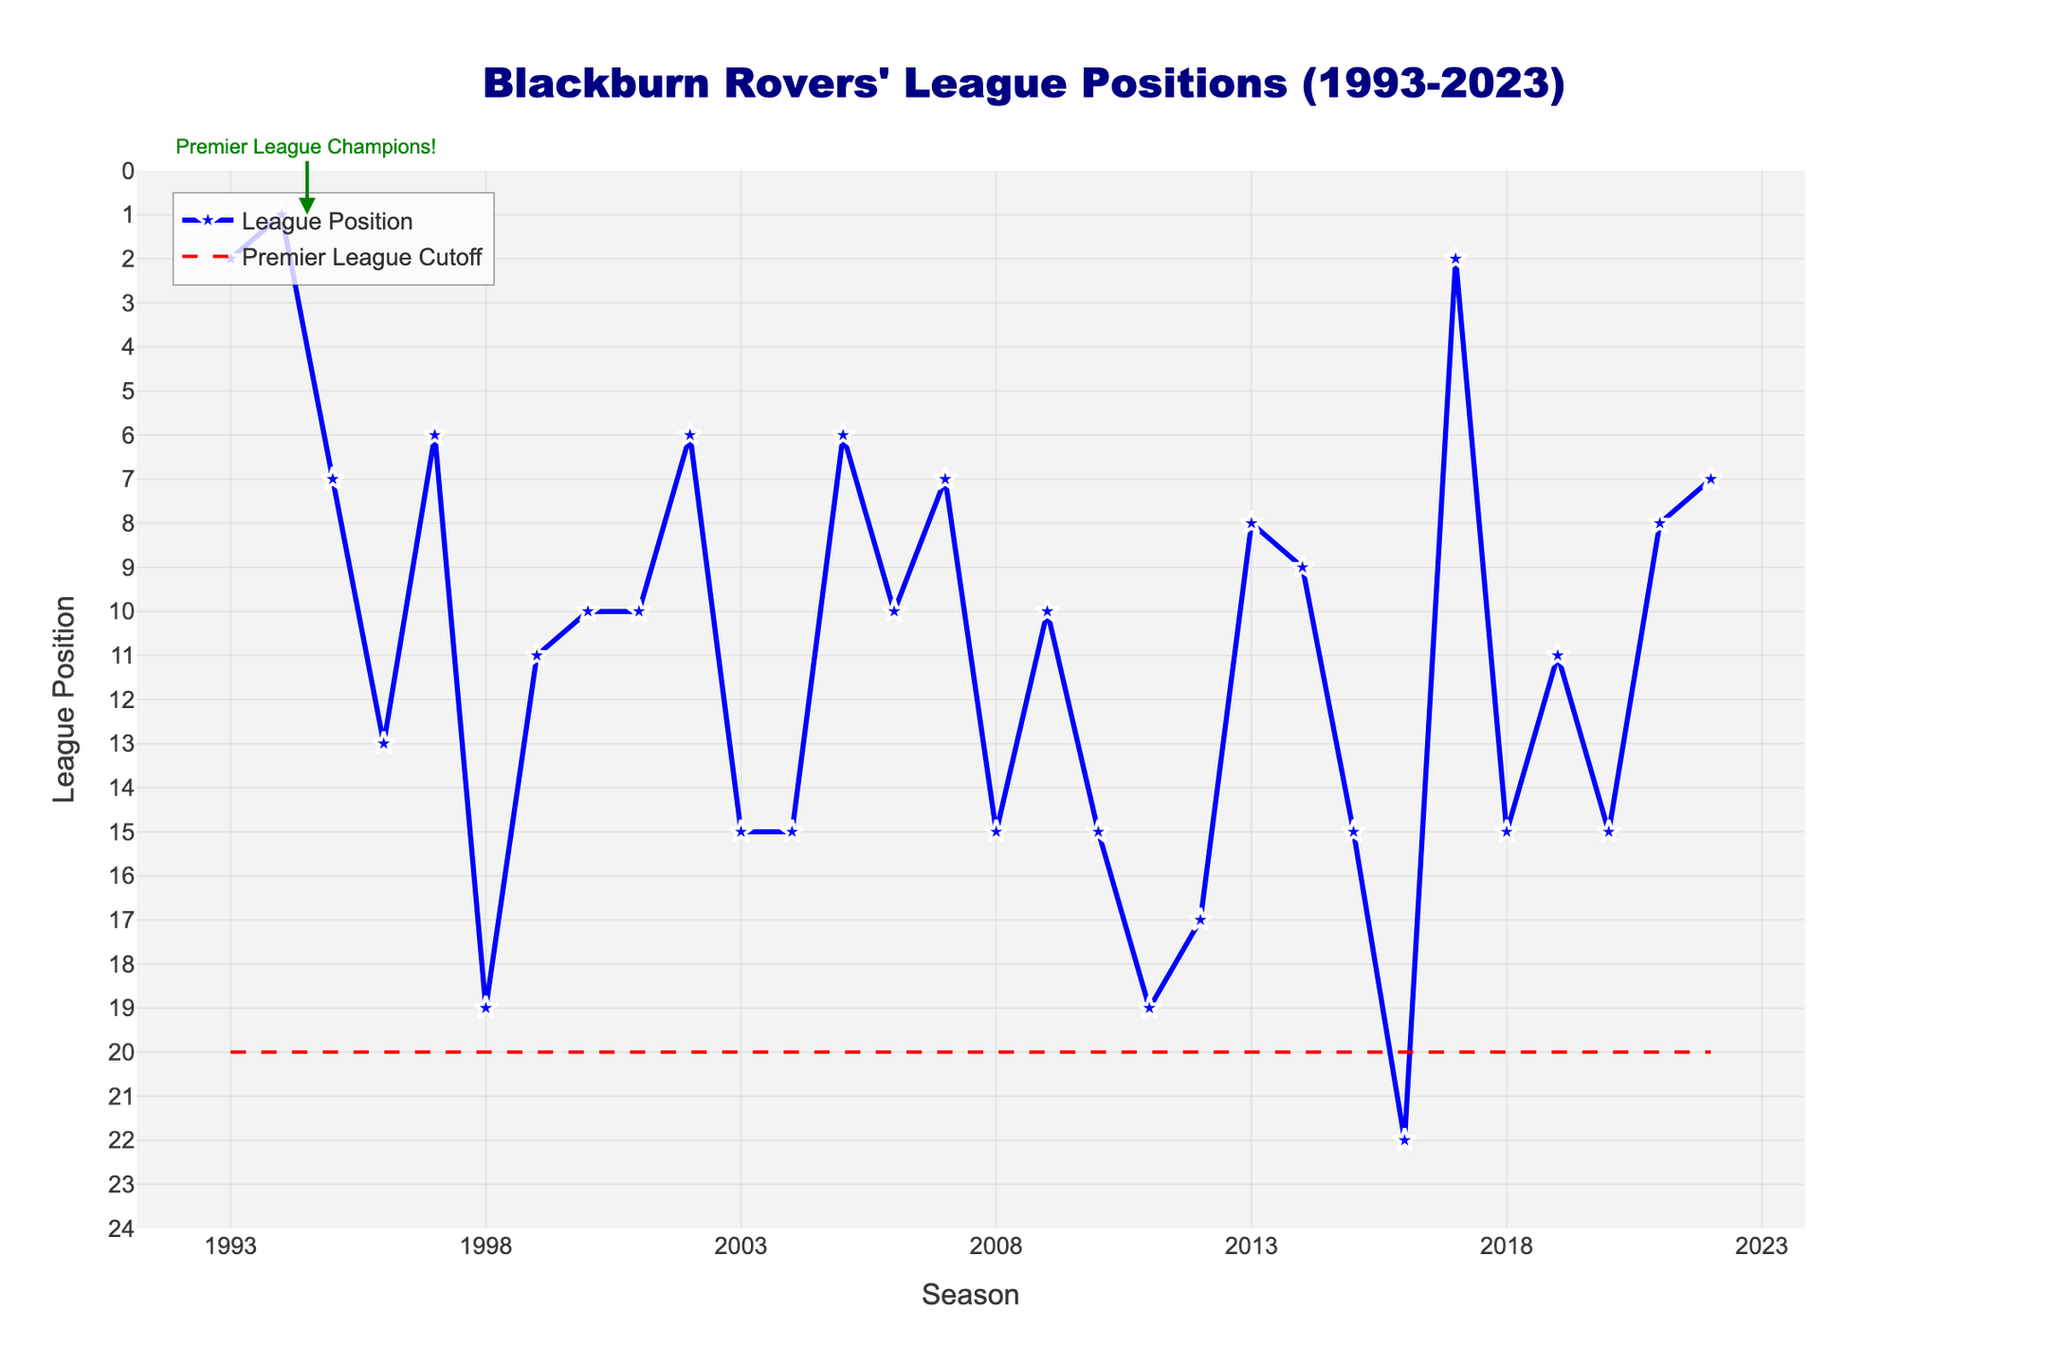What's the best league position Blackburn Rovers achieved in the past 30 seasons? The highest position Blackburn Rovers achieved is marked as 1 in the 1994-95 season. This is the lowest point on the y-axis.
Answer: 1 How many seasons did Blackburn Rovers finish in a position below the Premier League cutoff (above 20th position)? The figure shows 3 seasons where Blackburn Rovers finished above the 20th position line: 1998-99, 2011-12, and 2016-17.
Answer: 3 What is the range of league positions Blackburn Rovers occupied between the 2000-01 season and the 2004-05 season, inclusive? From the plot, the positions are:
2000-01: 10
2001-02: 10
2002-03: 6
2003-04: 15
2004-05: 15
The highest position is 6 (2002-03) and the lowest is 15 (2003-04, 2004-05).
Answer: 6 to 15 In which season did Blackburn Rovers finish with the same league position as the Premier League Champions annotation? The plotted annotation shows 1994-95 as the Premier League Champions, indicated by the arrow on the plot.
Answer: 1994-95 How many times did Blackburn Rovers finish exactly 15th between 1993-94 and 2022-23? The figure indicates the 15th positions in:
2003-04, 2004-05, 2008-09, 2010-11, 2015-16, 2018-19, 2020-21.
There are 7 instances of finishing 15th.
Answer: 7 If you average the league positions between the 1995-96 and 1997-98 seasons, what is the result? The league positions for these seasons are:
1995-96: 7,
1996-97: 13,
1997-98: 6.
The average is (7 + 13 + 6) / 3 = 8.67, approximately 9.
Answer: 9 